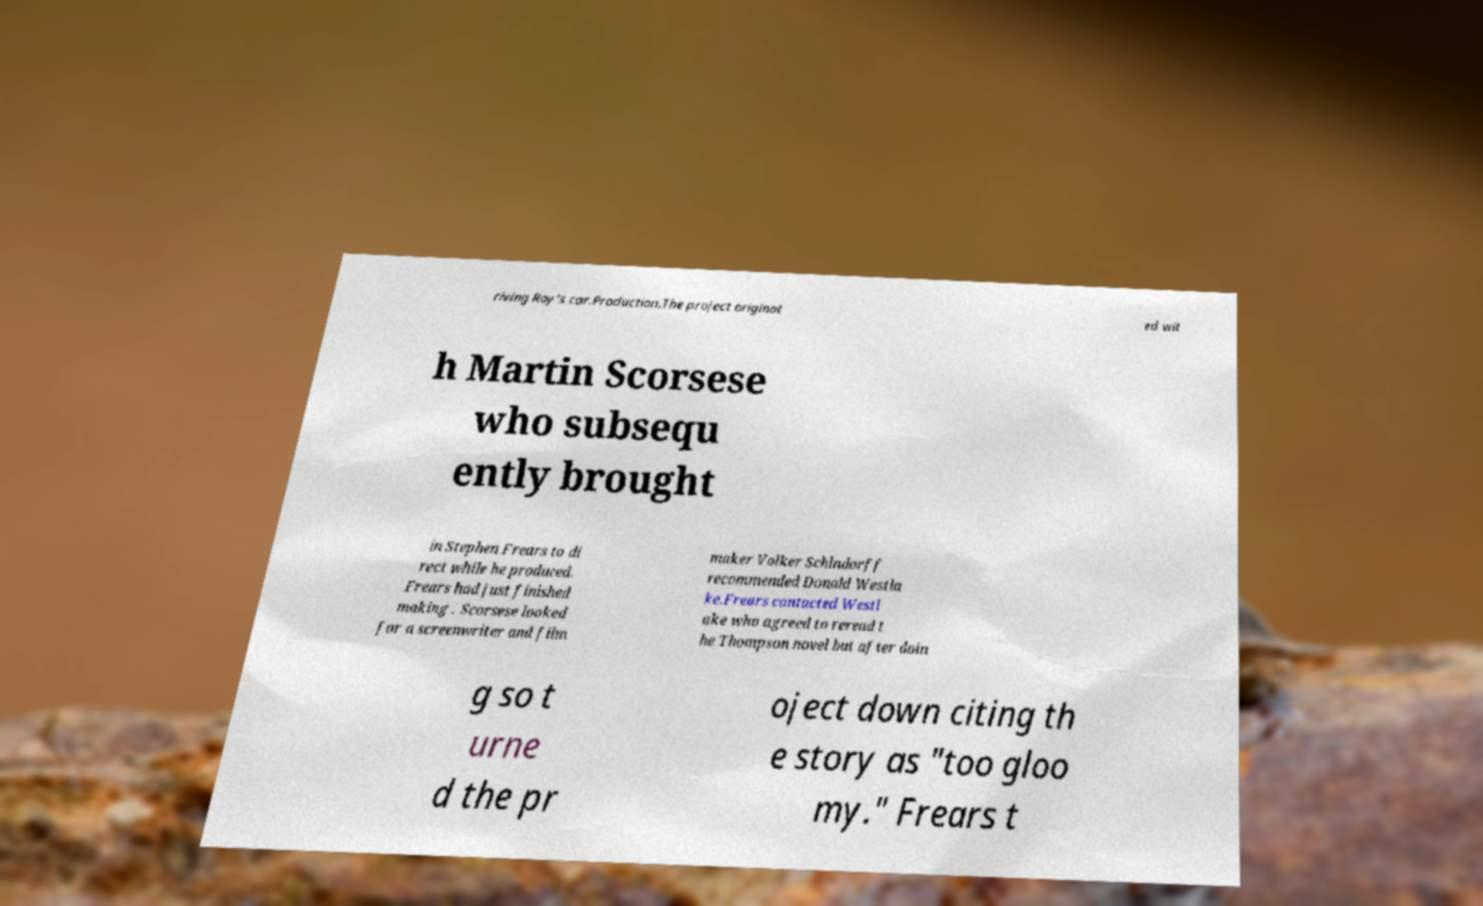There's text embedded in this image that I need extracted. Can you transcribe it verbatim? riving Roy's car.Production.The project originat ed wit h Martin Scorsese who subsequ ently brought in Stephen Frears to di rect while he produced. Frears had just finished making . Scorsese looked for a screenwriter and film maker Volker Schlndorff recommended Donald Westla ke.Frears contacted Westl ake who agreed to reread t he Thompson novel but after doin g so t urne d the pr oject down citing th e story as "too gloo my." Frears t 